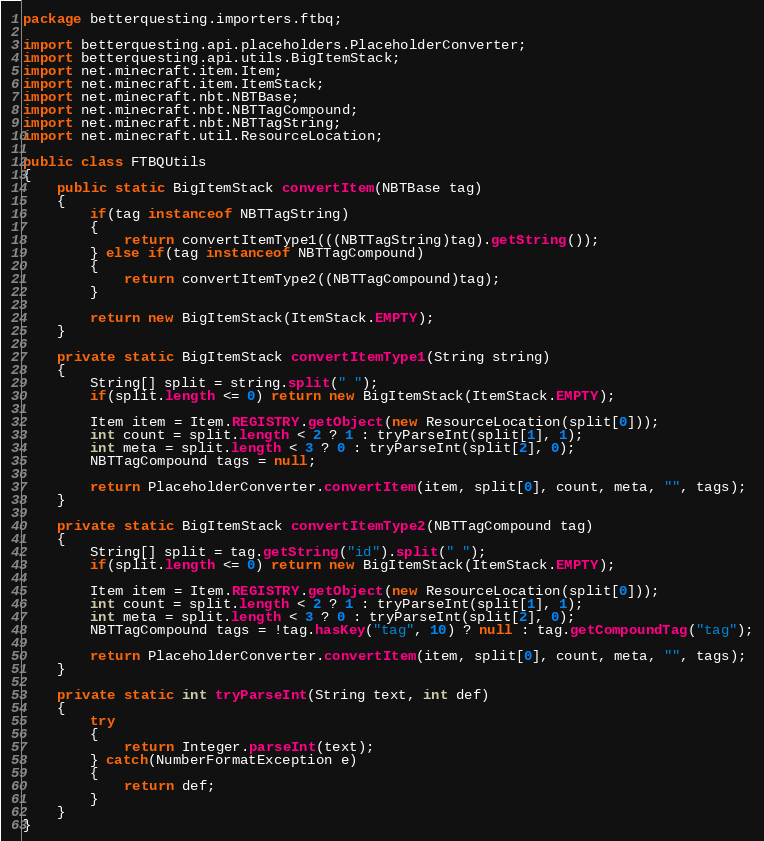<code> <loc_0><loc_0><loc_500><loc_500><_Java_>package betterquesting.importers.ftbq;

import betterquesting.api.placeholders.PlaceholderConverter;
import betterquesting.api.utils.BigItemStack;
import net.minecraft.item.Item;
import net.minecraft.item.ItemStack;
import net.minecraft.nbt.NBTBase;
import net.minecraft.nbt.NBTTagCompound;
import net.minecraft.nbt.NBTTagString;
import net.minecraft.util.ResourceLocation;

public class FTBQUtils
{
    public static BigItemStack convertItem(NBTBase tag)
    {
        if(tag instanceof NBTTagString)
        {
            return convertItemType1(((NBTTagString)tag).getString());
        } else if(tag instanceof NBTTagCompound)
        {
            return convertItemType2((NBTTagCompound)tag);
        }
        
        return new BigItemStack(ItemStack.EMPTY);
    }
    
    private static BigItemStack convertItemType1(String string)
    {
        String[] split = string.split(" ");
        if(split.length <= 0) return new BigItemStack(ItemStack.EMPTY);
        
        Item item = Item.REGISTRY.getObject(new ResourceLocation(split[0]));
        int count = split.length < 2 ? 1 : tryParseInt(split[1], 1);
        int meta = split.length < 3 ? 0 : tryParseInt(split[2], 0);
        NBTTagCompound tags = null;
        
        return PlaceholderConverter.convertItem(item, split[0], count, meta, "", tags);
    }
    
    private static BigItemStack convertItemType2(NBTTagCompound tag)
    {
        String[] split = tag.getString("id").split(" ");
        if(split.length <= 0) return new BigItemStack(ItemStack.EMPTY);
        
        Item item = Item.REGISTRY.getObject(new ResourceLocation(split[0]));
        int count = split.length < 2 ? 1 : tryParseInt(split[1], 1);
        int meta = split.length < 3 ? 0 : tryParseInt(split[2], 0);
        NBTTagCompound tags = !tag.hasKey("tag", 10) ? null : tag.getCompoundTag("tag");
        
        return PlaceholderConverter.convertItem(item, split[0], count, meta, "", tags);
    }
    
    private static int tryParseInt(String text, int def)
    {
        try
        {
            return Integer.parseInt(text);
        } catch(NumberFormatException e)
        {
            return def;
        }
    }
}
</code> 